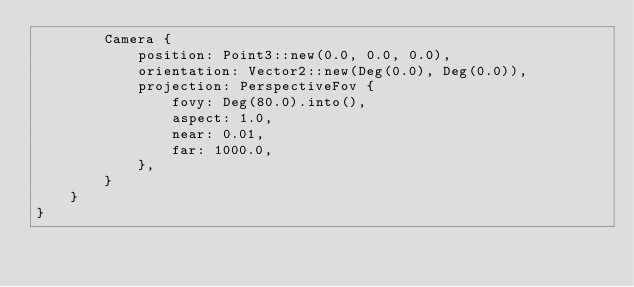Convert code to text. <code><loc_0><loc_0><loc_500><loc_500><_Rust_>        Camera {
            position: Point3::new(0.0, 0.0, 0.0),
            orientation: Vector2::new(Deg(0.0), Deg(0.0)),
            projection: PerspectiveFov {
                fovy: Deg(80.0).into(),
                aspect: 1.0,
                near: 0.01,
                far: 1000.0,
            },
        }
    }
}
</code> 